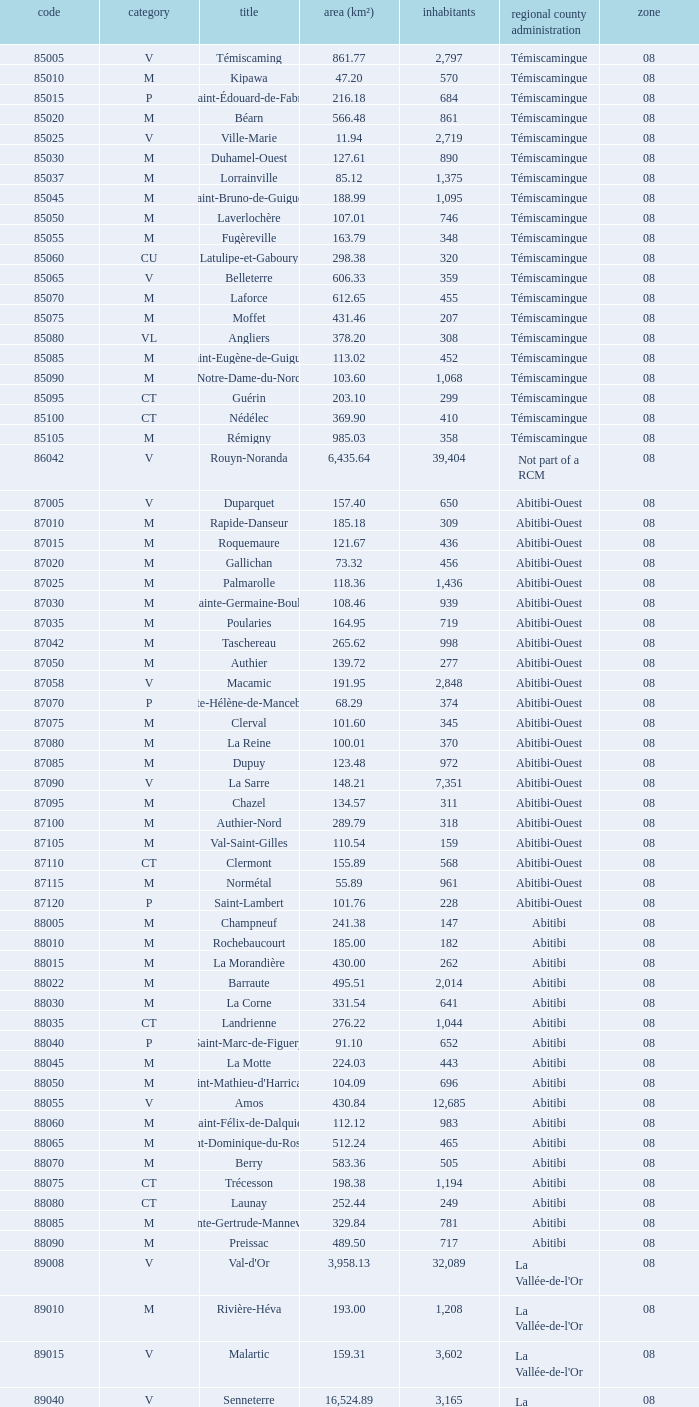What type has a population of 370? M. 